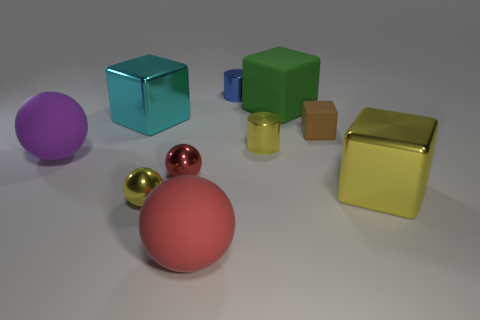Subtract all large purple rubber spheres. How many spheres are left? 3 Subtract all yellow cubes. How many red spheres are left? 2 Subtract all cyan cubes. How many cubes are left? 3 Subtract all cylinders. How many objects are left? 8 Subtract 2 blocks. How many blocks are left? 2 Subtract all yellow cylinders. Subtract all tiny yellow metal things. How many objects are left? 7 Add 1 tiny red balls. How many tiny red balls are left? 2 Add 5 cubes. How many cubes exist? 9 Subtract 1 red spheres. How many objects are left? 9 Subtract all yellow blocks. Subtract all yellow cylinders. How many blocks are left? 3 